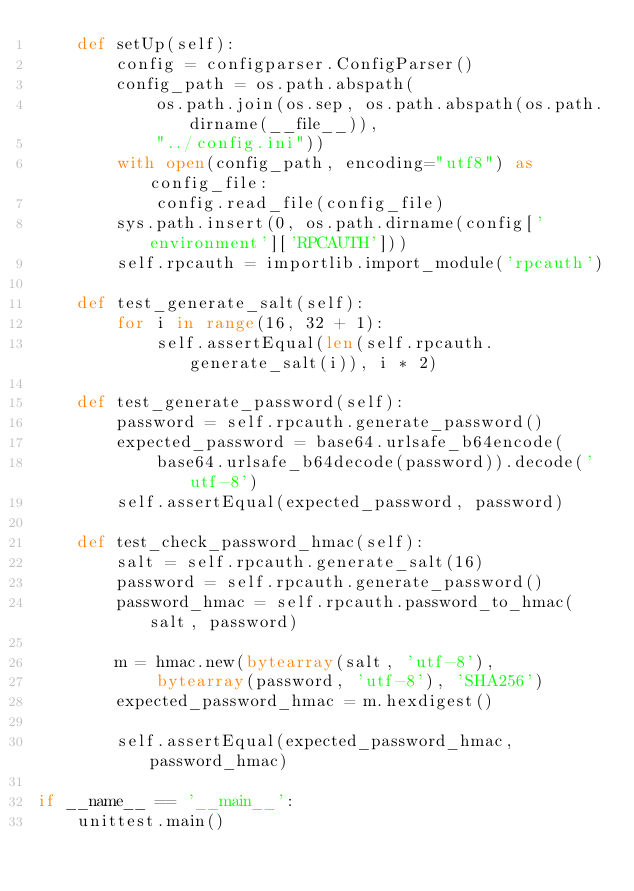Convert code to text. <code><loc_0><loc_0><loc_500><loc_500><_Python_>    def setUp(self):
        config = configparser.ConfigParser()
        config_path = os.path.abspath(
            os.path.join(os.sep, os.path.abspath(os.path.dirname(__file__)),
            "../config.ini"))
        with open(config_path, encoding="utf8") as config_file:
            config.read_file(config_file)
        sys.path.insert(0, os.path.dirname(config['environment']['RPCAUTH']))
        self.rpcauth = importlib.import_module('rpcauth')

    def test_generate_salt(self):
        for i in range(16, 32 + 1):
            self.assertEqual(len(self.rpcauth.generate_salt(i)), i * 2)

    def test_generate_password(self):
        password = self.rpcauth.generate_password()
        expected_password = base64.urlsafe_b64encode(
            base64.urlsafe_b64decode(password)).decode('utf-8')
        self.assertEqual(expected_password, password)

    def test_check_password_hmac(self):
        salt = self.rpcauth.generate_salt(16)
        password = self.rpcauth.generate_password()
        password_hmac = self.rpcauth.password_to_hmac(salt, password)

        m = hmac.new(bytearray(salt, 'utf-8'),
            bytearray(password, 'utf-8'), 'SHA256')
        expected_password_hmac = m.hexdigest()

        self.assertEqual(expected_password_hmac, password_hmac)

if __name__ == '__main__':
    unittest.main()
</code> 